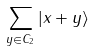<formula> <loc_0><loc_0><loc_500><loc_500>\sum _ { y \in C _ { 2 } } | x + y \rangle</formula> 